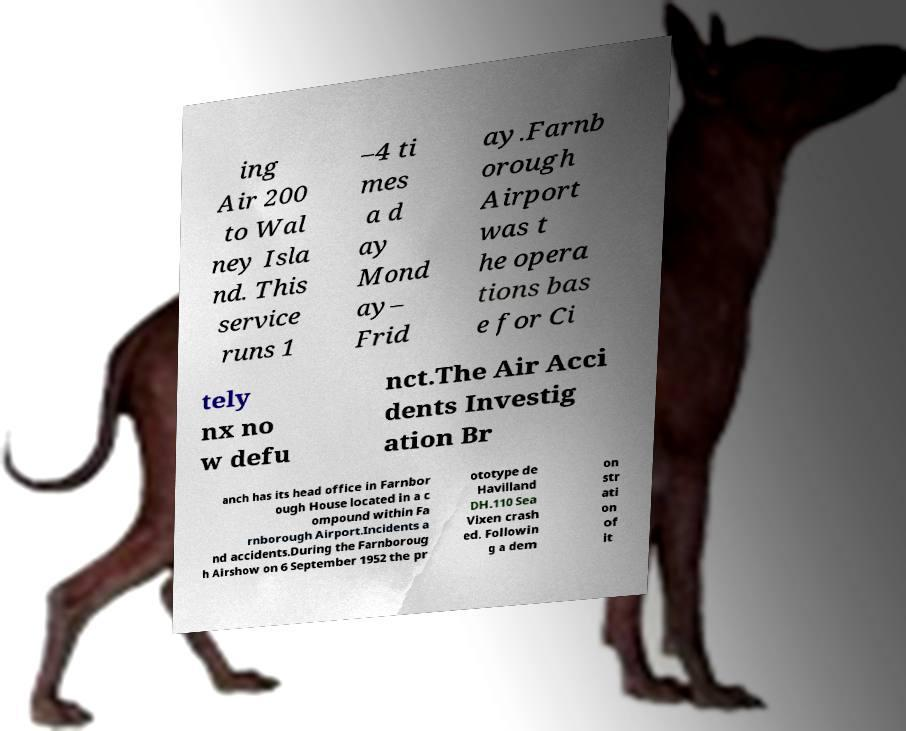Please read and relay the text visible in this image. What does it say? ing Air 200 to Wal ney Isla nd. This service runs 1 –4 ti mes a d ay Mond ay– Frid ay.Farnb orough Airport was t he opera tions bas e for Ci tely nx no w defu nct.The Air Acci dents Investig ation Br anch has its head office in Farnbor ough House located in a c ompound within Fa rnborough Airport.Incidents a nd accidents.During the Farnboroug h Airshow on 6 September 1952 the pr ototype de Havilland DH.110 Sea Vixen crash ed. Followin g a dem on str ati on of it 